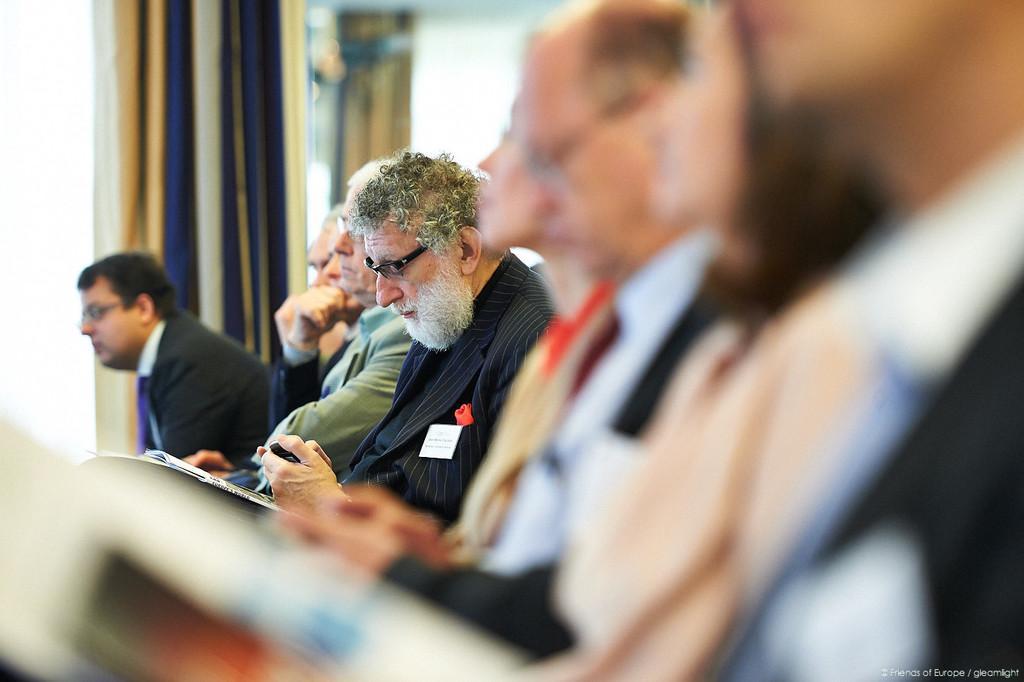Please provide a concise description of this image. Bottom portion of the picture is blur and we can see watermark. Background portion of the picture is blurry and we can see a curtain. In this picture we can see the men. Among them few wore spectacles. We can see a man wearing a blazer, holding an object. In this picture papers are visible. 